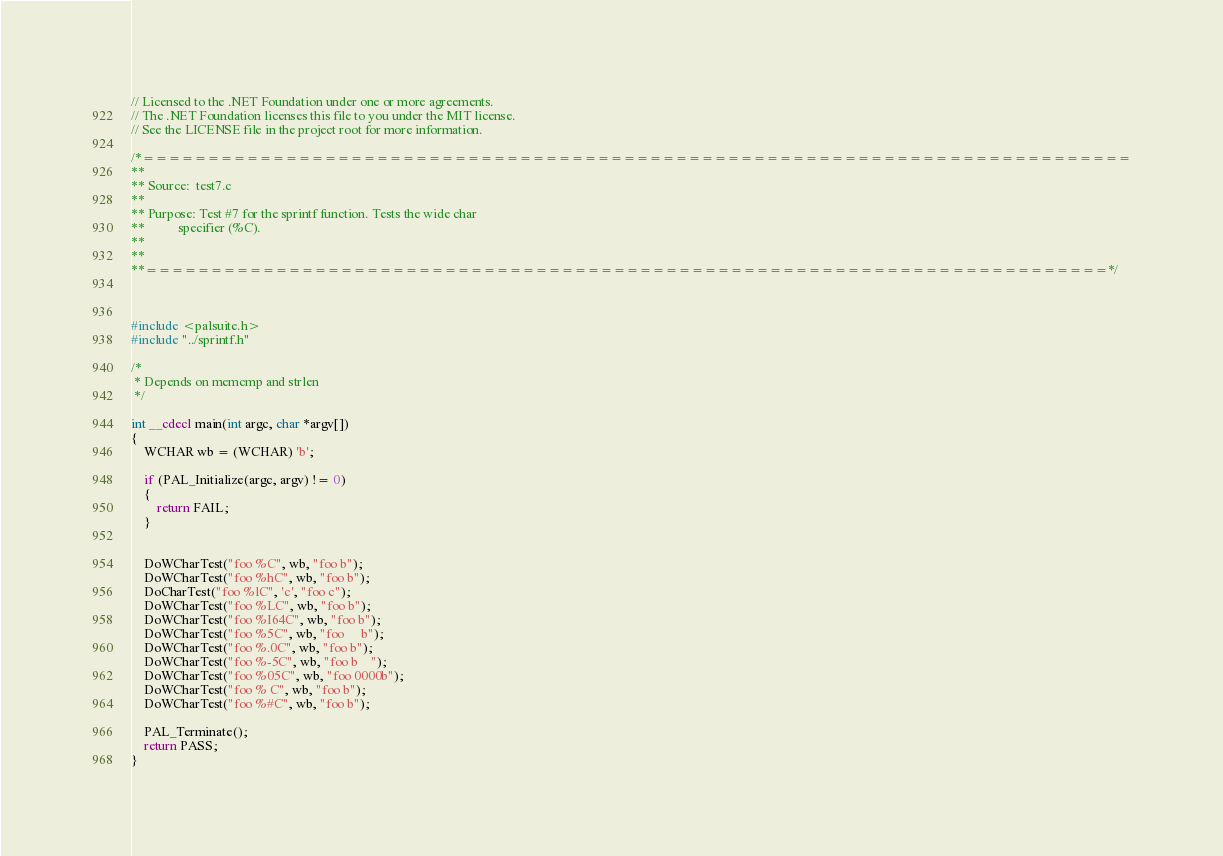<code> <loc_0><loc_0><loc_500><loc_500><_C_>// Licensed to the .NET Foundation under one or more agreements.
// The .NET Foundation licenses this file to you under the MIT license.
// See the LICENSE file in the project root for more information.

/*============================================================================
**
** Source:  test7.c
**
** Purpose: Test #7 for the sprintf function. Tests the wide char
**          specifier (%C).
**
**
**==========================================================================*/



#include <palsuite.h>
#include "../sprintf.h"

/* 
 * Depends on memcmp and strlen
 */

int __cdecl main(int argc, char *argv[])
{
    WCHAR wb = (WCHAR) 'b';
    
    if (PAL_Initialize(argc, argv) != 0)
    {
        return FAIL;
    }


    DoWCharTest("foo %C", wb, "foo b");
    DoWCharTest("foo %hC", wb, "foo b");
    DoCharTest("foo %lC", 'c', "foo c");
    DoWCharTest("foo %LC", wb, "foo b");
    DoWCharTest("foo %I64C", wb, "foo b");
    DoWCharTest("foo %5C", wb, "foo     b");
    DoWCharTest("foo %.0C", wb, "foo b");
    DoWCharTest("foo %-5C", wb, "foo b    ");
    DoWCharTest("foo %05C", wb, "foo 0000b");
    DoWCharTest("foo % C", wb, "foo b");
    DoWCharTest("foo %#C", wb, "foo b");

    PAL_Terminate();
    return PASS;
}

</code> 